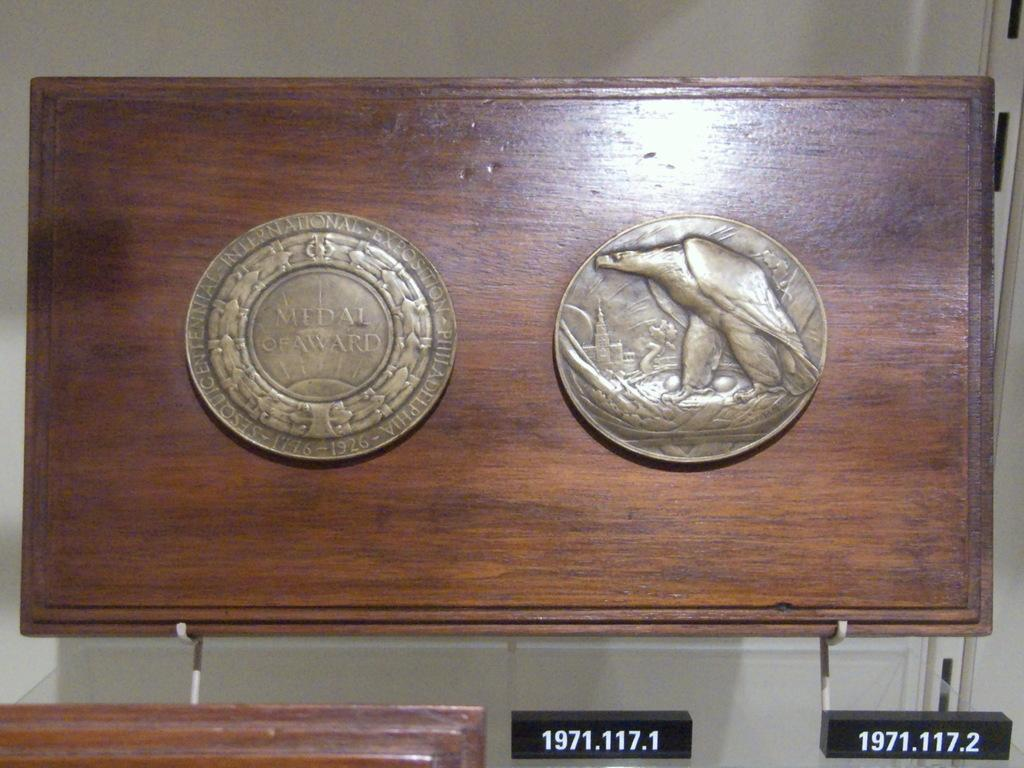<image>
Provide a brief description of the given image. Two round gold discs are in the middle of a wood plaque, one reads MEDAL OF AWARD. 